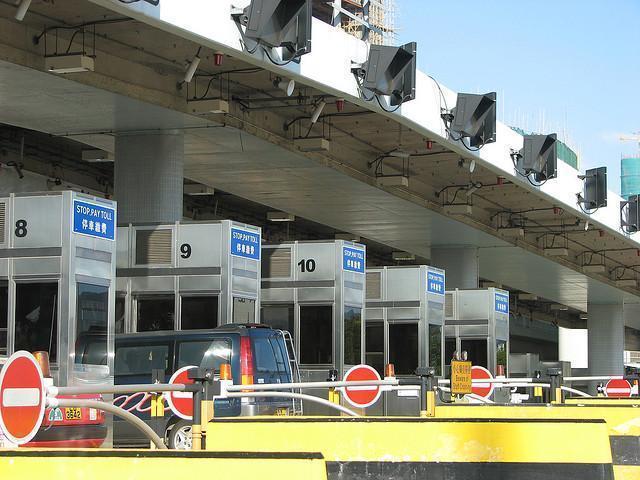What does the red sign with a minus symbol on it usually mean?
Make your selection from the four choices given to correctly answer the question.
Options: Free parking, no parking, no entering, crossing permitted. No entering. 